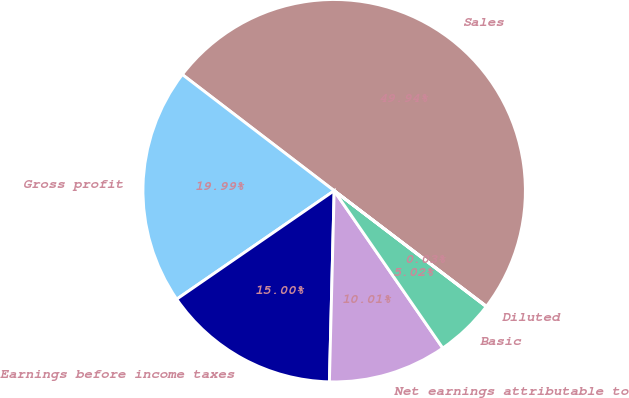<chart> <loc_0><loc_0><loc_500><loc_500><pie_chart><fcel>Sales<fcel>Gross profit<fcel>Earnings before income taxes<fcel>Net earnings attributable to<fcel>Basic<fcel>Diluted<nl><fcel>49.93%<fcel>19.99%<fcel>15.0%<fcel>10.01%<fcel>5.02%<fcel>0.03%<nl></chart> 